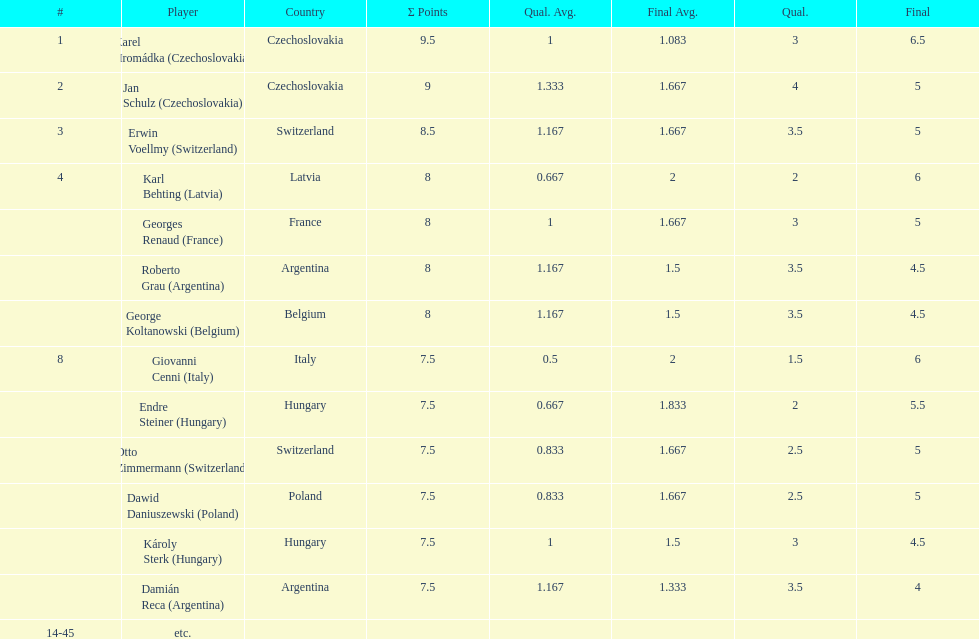How many players had final scores higher than 5? 4. 